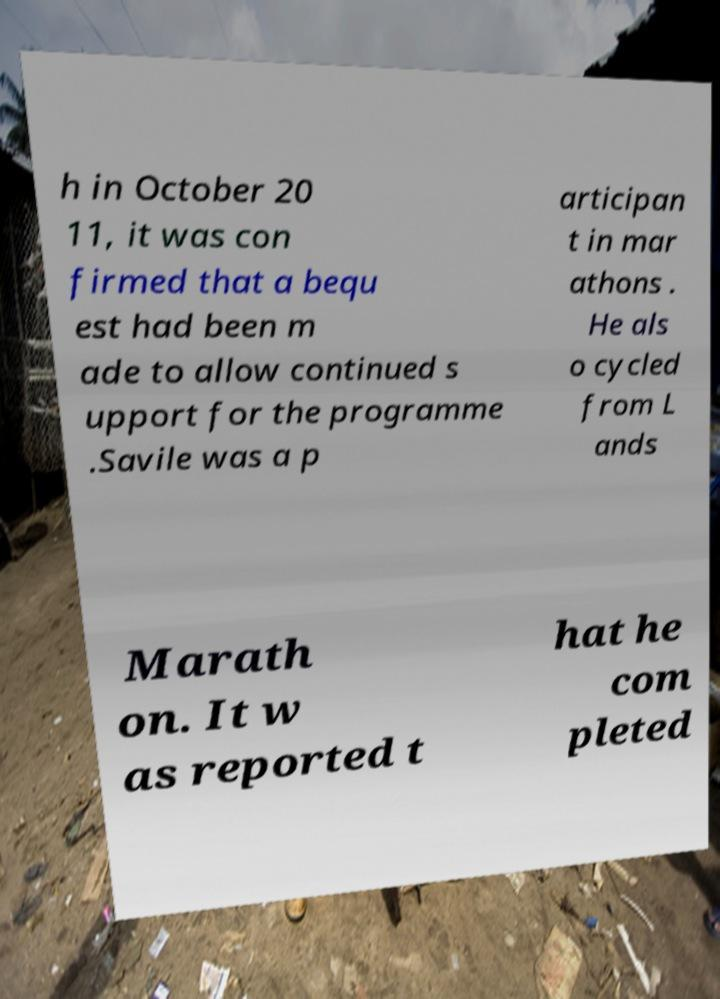Can you read and provide the text displayed in the image?This photo seems to have some interesting text. Can you extract and type it out for me? h in October 20 11, it was con firmed that a bequ est had been m ade to allow continued s upport for the programme .Savile was a p articipan t in mar athons . He als o cycled from L ands Marath on. It w as reported t hat he com pleted 